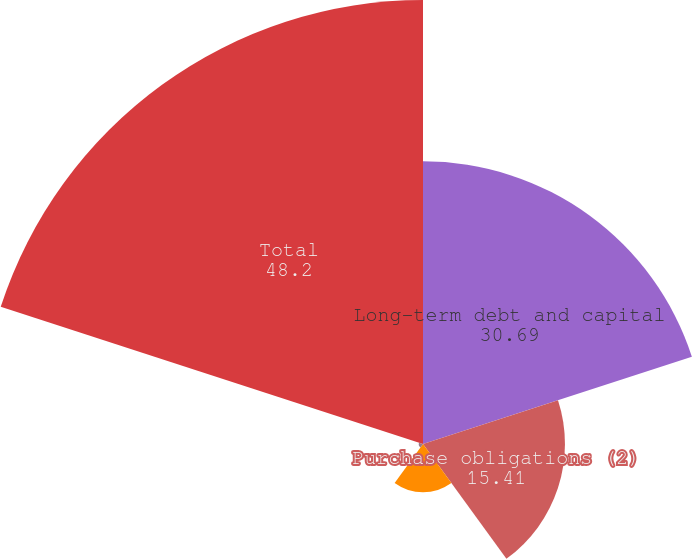<chart> <loc_0><loc_0><loc_500><loc_500><pie_chart><fcel>Long-term debt and capital<fcel>Purchase obligations (2)<fcel>Operating lease obligations<fcel>Other long-term liabilities<fcel>Total<nl><fcel>30.69%<fcel>15.41%<fcel>5.24%<fcel>0.46%<fcel>48.2%<nl></chart> 